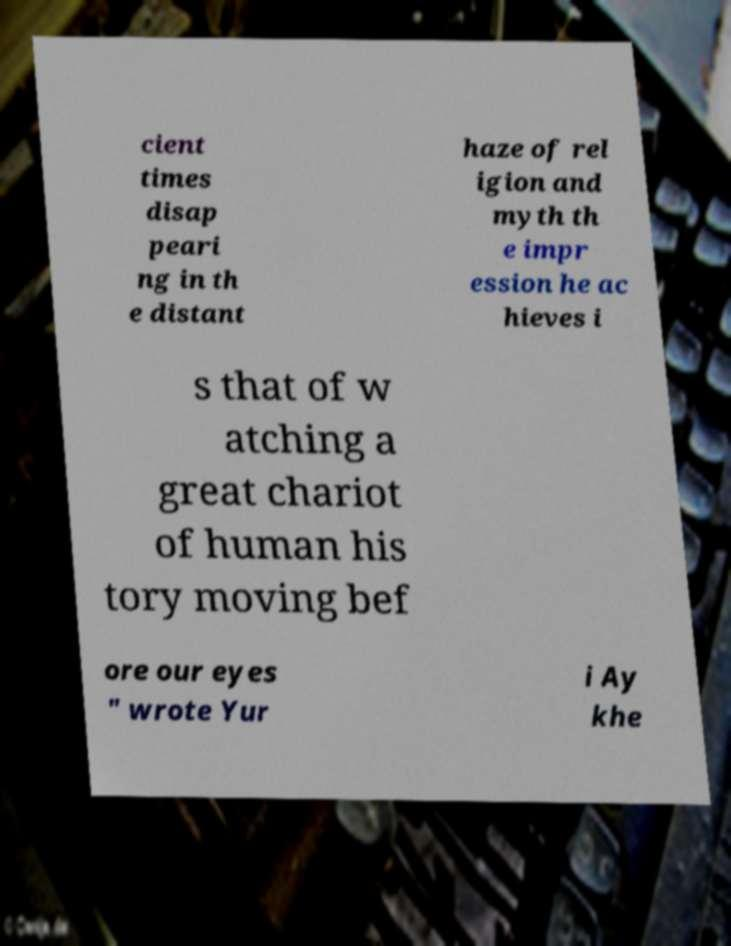Please identify and transcribe the text found in this image. cient times disap peari ng in th e distant haze of rel igion and myth th e impr ession he ac hieves i s that of w atching a great chariot of human his tory moving bef ore our eyes " wrote Yur i Ay khe 